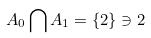<formula> <loc_0><loc_0><loc_500><loc_500>A _ { 0 } \bigcap A _ { 1 } = \{ 2 \} \ni 2</formula> 